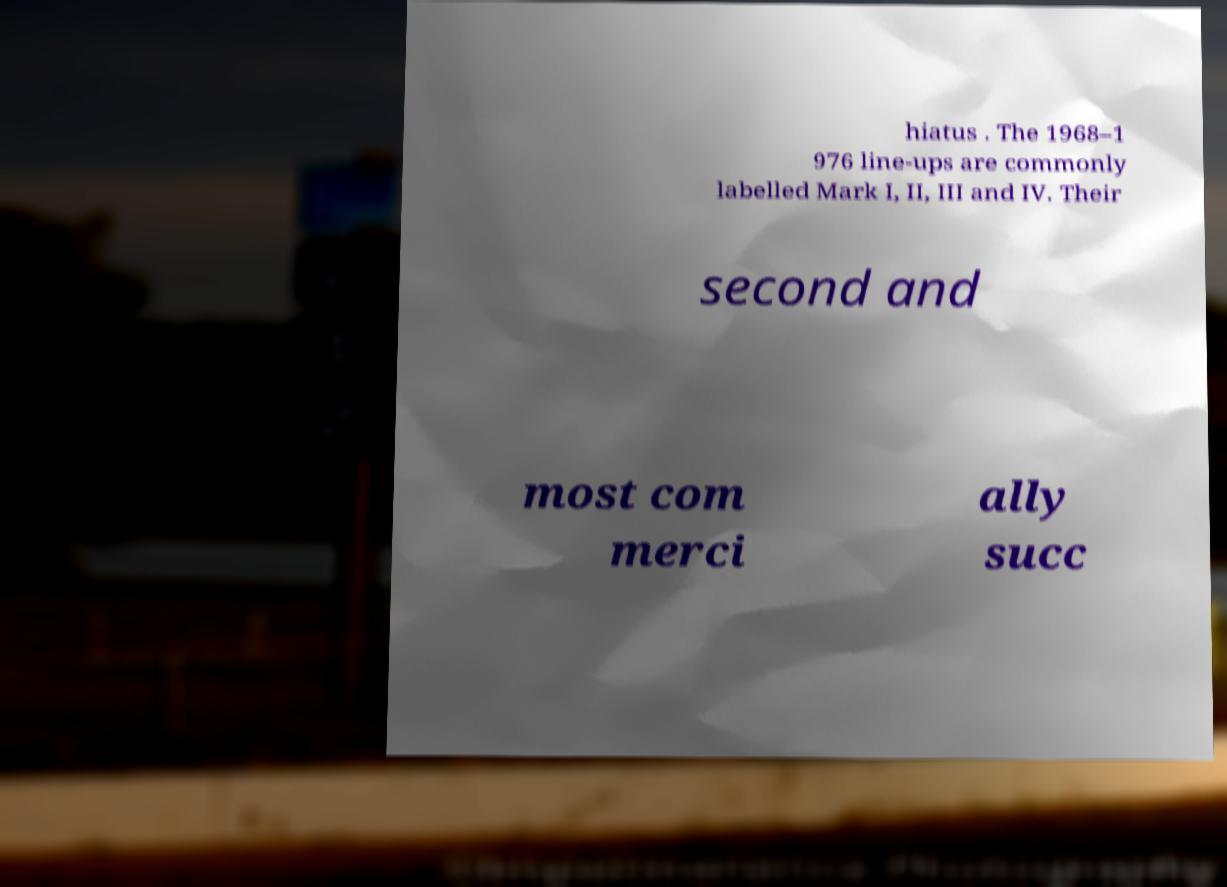For documentation purposes, I need the text within this image transcribed. Could you provide that? hiatus . The 1968–1 976 line-ups are commonly labelled Mark I, II, III and IV. Their second and most com merci ally succ 